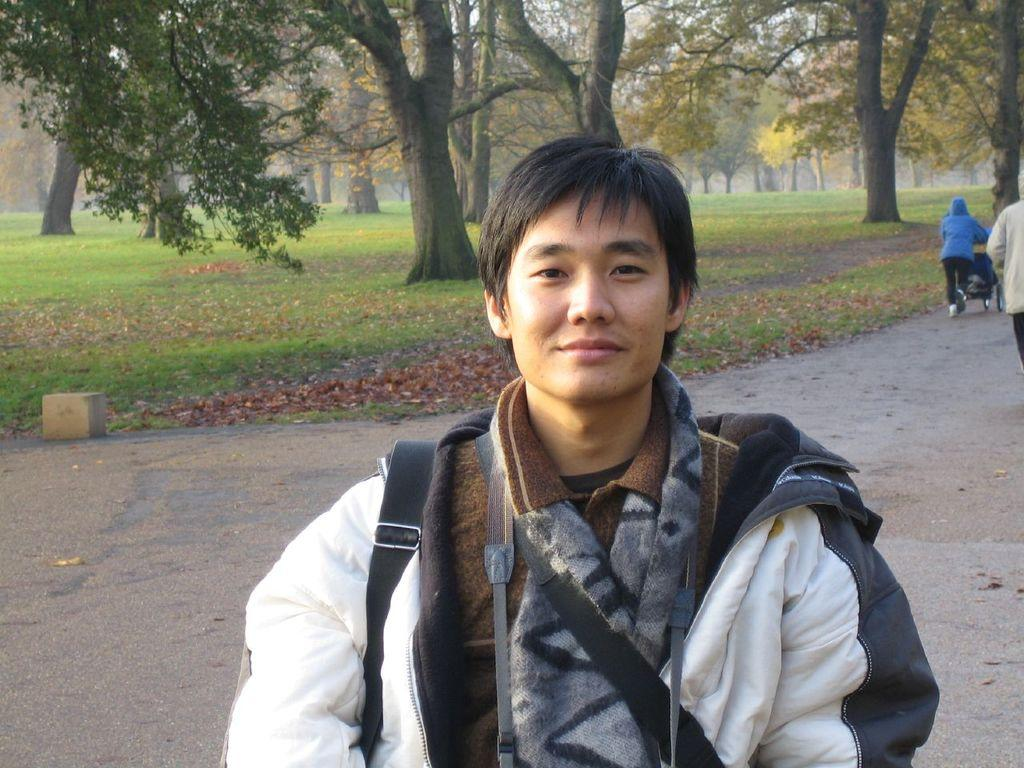Who is present in the image? There is a man in the image. What is the man doing in the image? The man is smiling. Can you describe the people behind the man? There are two people behind the man. What is on the road in the image? There is a stroller on the road. What can be seen in the background of the image? Trees and grass are visible in the background of the image. What type of oil is being used to maintain the route in the image? There is no mention of oil or a route in the image; it features a man, two people, a stroller, and a background with trees and grass. 